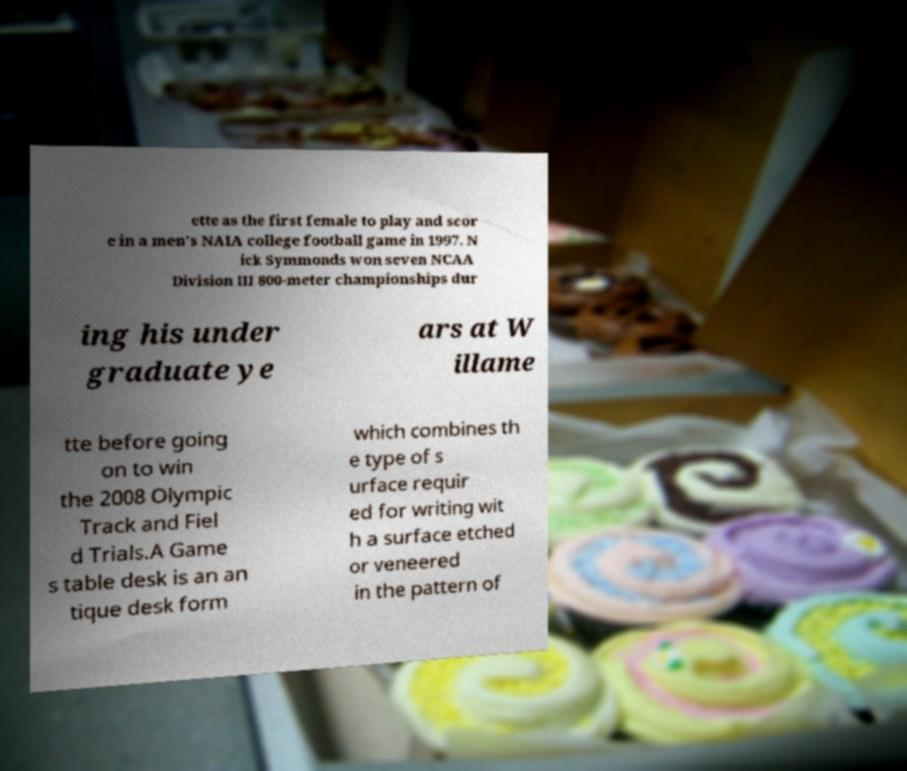Please identify and transcribe the text found in this image. ette as the first female to play and scor e in a men's NAIA college football game in 1997. N ick Symmonds won seven NCAA Division III 800-meter championships dur ing his under graduate ye ars at W illame tte before going on to win the 2008 Olympic Track and Fiel d Trials.A Game s table desk is an an tique desk form which combines th e type of s urface requir ed for writing wit h a surface etched or veneered in the pattern of 